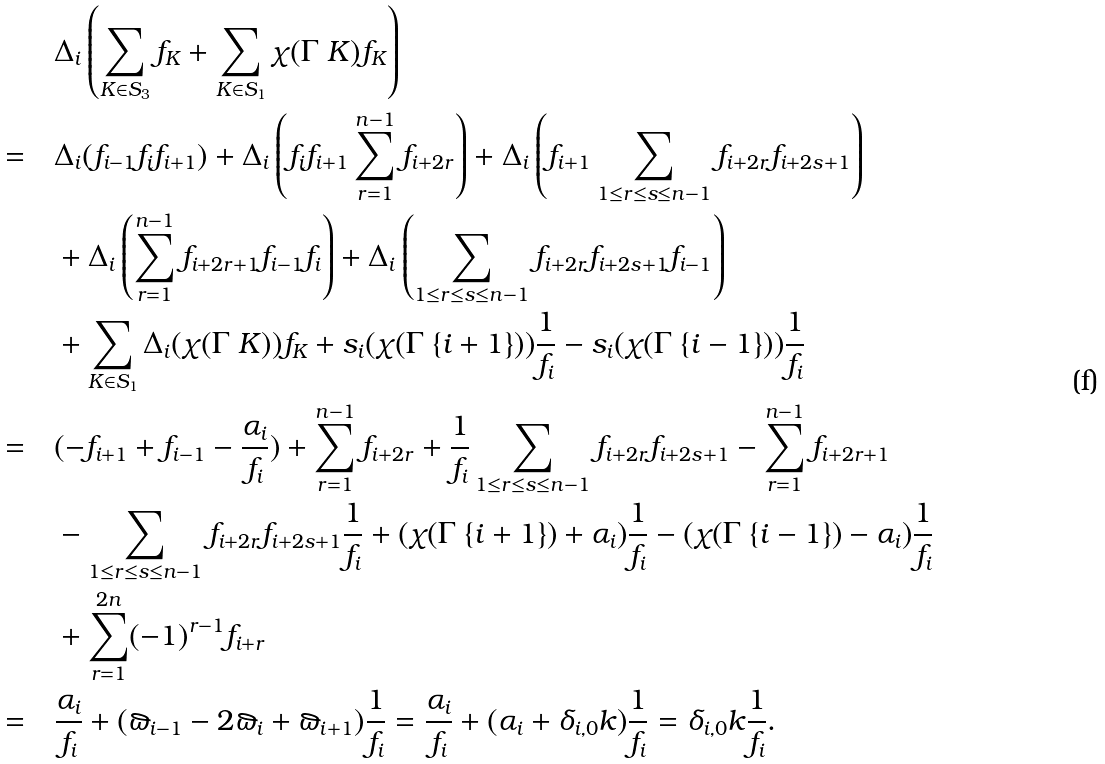<formula> <loc_0><loc_0><loc_500><loc_500>& \quad \Delta _ { i } \left ( \sum _ { K \in S _ { 3 } } f _ { K } + \sum _ { K \in S _ { 1 } } \chi ( \Gamma \ K ) f _ { K } \right ) \\ = & \quad \Delta _ { i } ( f _ { i - 1 } f _ { i } f _ { i + 1 } ) + \Delta _ { i } \left ( f _ { i } f _ { i + 1 } \sum _ { r = 1 } ^ { n - 1 } f _ { i + 2 r } \right ) + \Delta _ { i } \left ( f _ { i + 1 } \sum _ { 1 \leq r \leq s \leq n - 1 } f _ { i + 2 r } f _ { i + 2 s + 1 } \right ) \\ & \quad + \Delta _ { i } \left ( \sum _ { r = 1 } ^ { n - 1 } f _ { i + 2 r + 1 } f _ { i - 1 } f _ { i } \right ) + \Delta _ { i } \left ( \sum _ { 1 \leq r \leq s \leq n - 1 } f _ { i + 2 r } f _ { i + 2 s + 1 } f _ { i - 1 } \right ) \\ & \quad + \sum _ { K \in S _ { 1 } } \Delta _ { i } ( \chi ( \Gamma \ K ) ) f _ { K } + s _ { i } ( \chi ( \Gamma \ \{ i + 1 \} ) ) \frac { 1 } { f _ { i } } - s _ { i } ( \chi ( \Gamma \ \{ i - 1 \} ) ) \frac { 1 } { f _ { i } } \\ = & \quad ( - f _ { i + 1 } + f _ { i - 1 } - \frac { \alpha _ { i } } { f _ { i } } ) + \sum _ { r = 1 } ^ { n - 1 } f _ { i + 2 r } + \frac { 1 } { f _ { i } } \sum _ { 1 \leq r \leq s \leq n - 1 } f _ { i + 2 r } f _ { i + 2 s + 1 } - \sum _ { r = 1 } ^ { n - 1 } f _ { i + 2 r + 1 } \\ & \quad - \sum _ { 1 \leq r \leq s \leq n - 1 } f _ { i + 2 r } f _ { i + 2 s + 1 } \frac { 1 } { f _ { i } } + ( \chi ( \Gamma \ \{ i + 1 \} ) + \alpha _ { i } ) \frac { 1 } { f _ { i } } - ( \chi ( \Gamma \ \{ i - 1 \} ) - \alpha _ { i } ) \frac { 1 } { f _ { i } } \\ & \quad + \sum _ { r = 1 } ^ { 2 n } ( - 1 ) ^ { r - 1 } f _ { i + r } \\ = & \quad \frac { \alpha _ { i } } { f _ { i } } + ( \varpi _ { i - 1 } - 2 \varpi _ { i } + \varpi _ { i + 1 } ) \frac { 1 } { f _ { i } } = \frac { \alpha _ { i } } { f _ { i } } + ( \alpha _ { i } + \delta _ { i , 0 } k ) \frac { 1 } { f _ { i } } = \delta _ { i , 0 } k \frac { 1 } { f _ { i } } .</formula> 